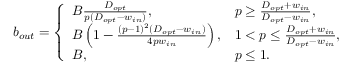Convert formula to latex. <formula><loc_0><loc_0><loc_500><loc_500>b _ { o u t } = \left \{ \begin{array} { l l } { B \frac { D _ { o p t } } { p ( D _ { o p t } - w _ { i n } ) } , } & { p \geq \frac { D _ { o p t } + w _ { i n } } { D _ { o p t } - w _ { i n } } , } \\ { B \left ( 1 - \frac { ( p - 1 ) ^ { 2 } ( D _ { o p t } - w _ { i n } ) } { 4 p w _ { i n } } \right ) , } & { 1 < p \leq \frac { D _ { o p t } + w _ { i n } } { D _ { o p t } - w _ { i n } } , } \\ { B , } & { p \leq 1 . } \end{array}</formula> 